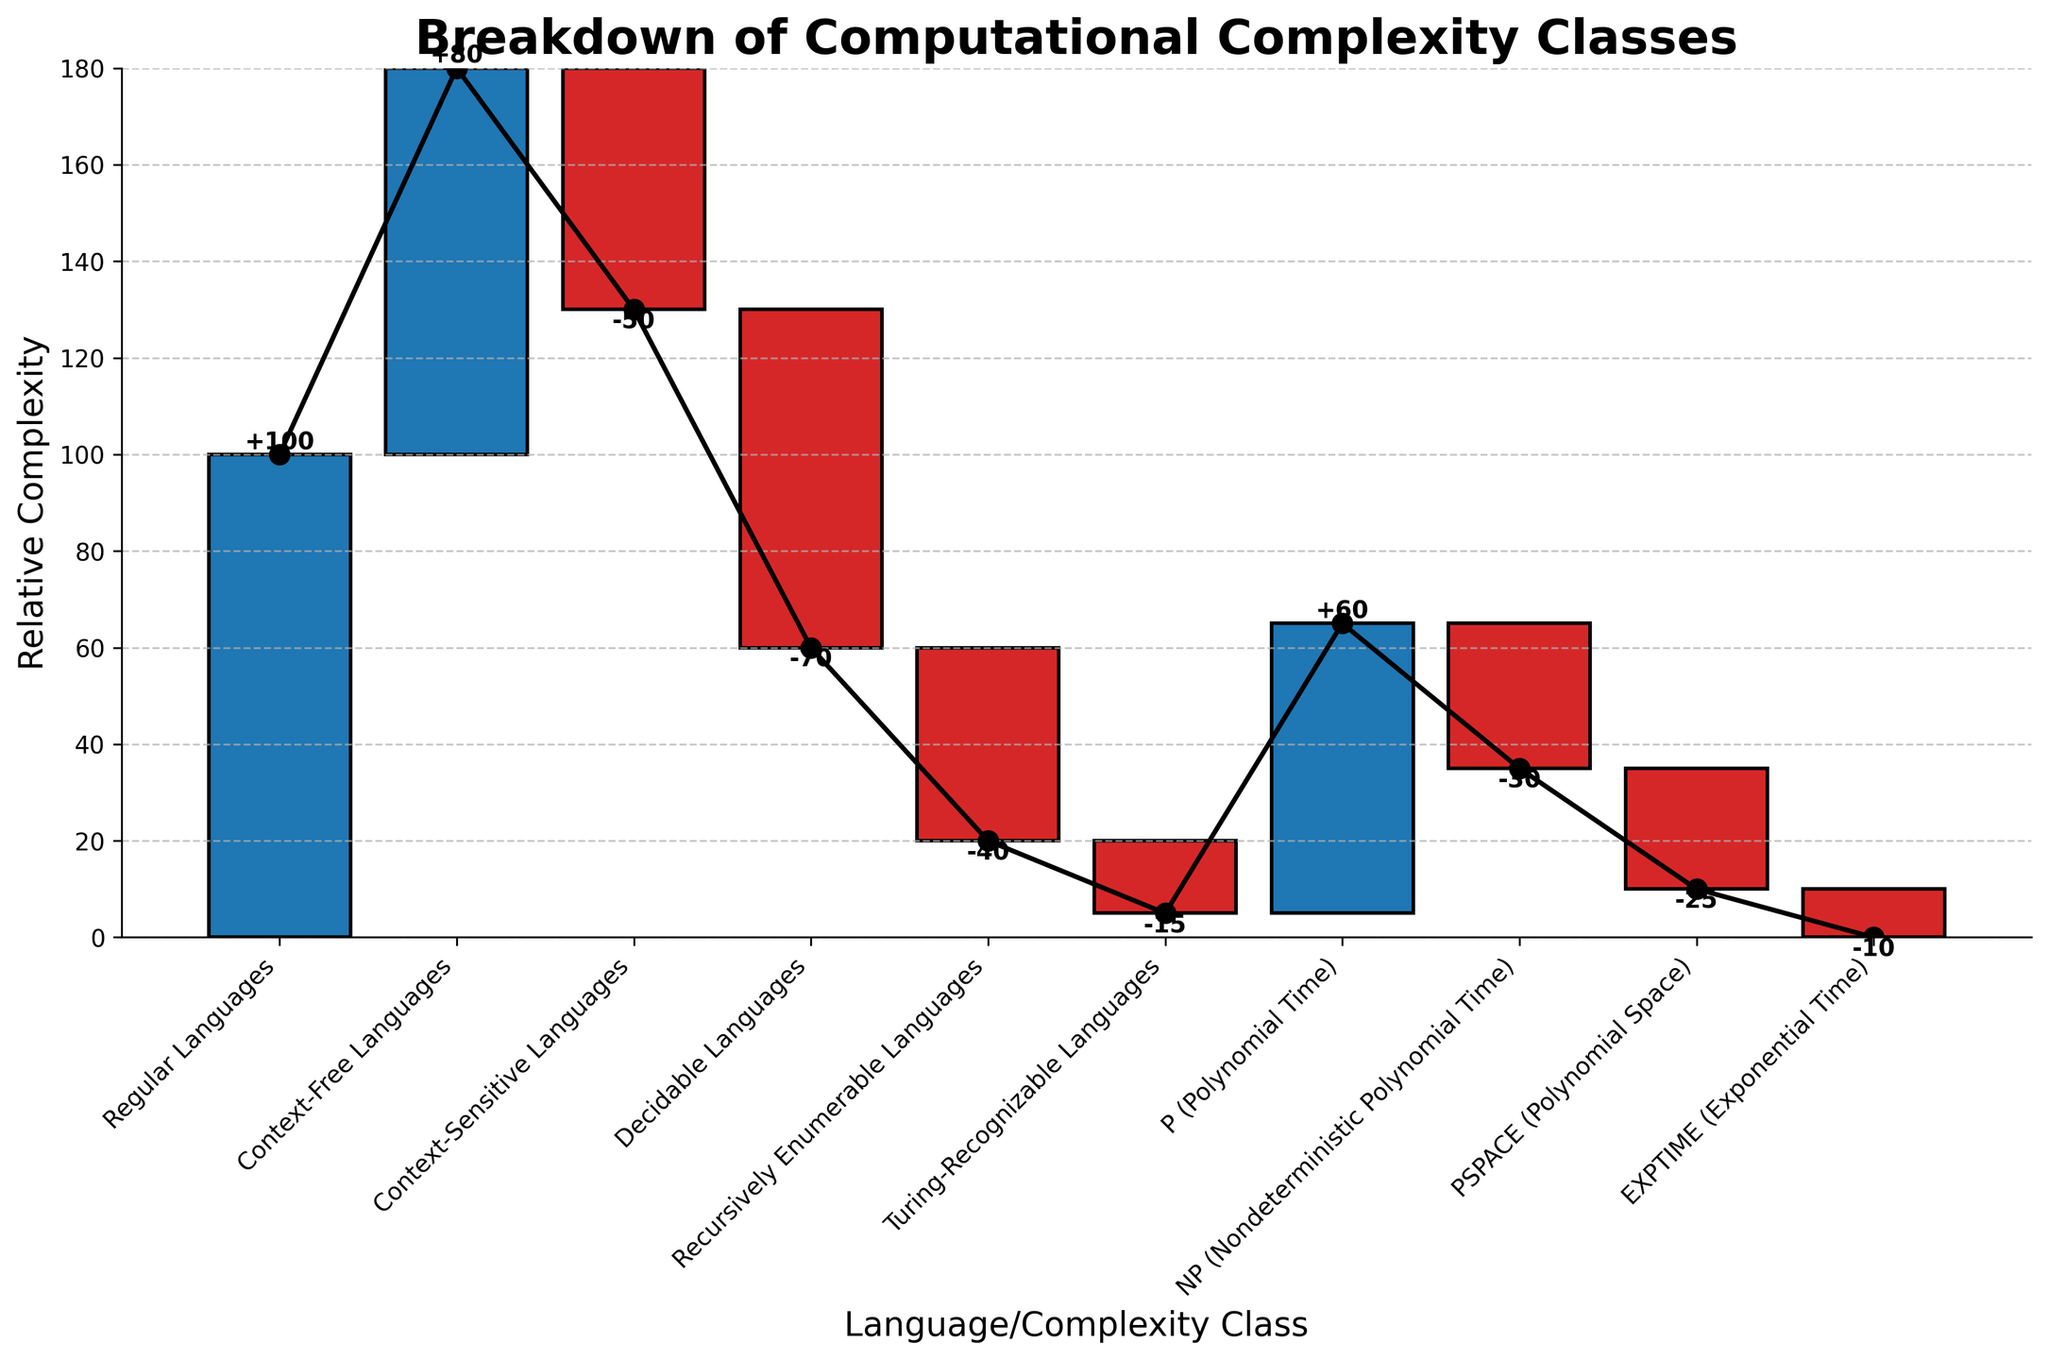What is the title of the figure? The title of the figure is usually displayed at the top in larger and bolder text. By looking at the top of the chart, you can see that the title reads "Breakdown of Computational Complexity Classes".
Answer: Breakdown of Computational Complexity Classes How many different categories are shown in the figure? The number of categories can be determined by counting the distinct labels along the x-axis of the chart. By counting these, we find there are a total of 10 categories.
Answer: 10 Which category has the highest positive value? To identify the highest positive value, compare all positive values shown on the bars. "Regular Languages" has a value of 100, which is higher than any other positive value in this dataset.
Answer: Regular Languages How much does the "P (Polynomial Time)" category contribute to the overall complexity? Referring to the figure, the "P (Polynomial Time)" category shows a positive value. By reading the value label above the bar, we see it contributes +60 to the overall complexity.
Answer: +60 What is the cumulative complexity after "Context-Free Languages"? To find the cumulative complexity after "Context-Free Languages", add the first two values: 100 (Regular Languages) + 80 (Context-Free Languages) = 180. This is confirmed by the point in the cumulative line above the "Context-Free Languages" bar.
Answer: 180 Which category is responsible for the largest decrease in complexity? The largest decrease in complexity can be identified by comparing the negative values on the bars. "Decidable Languages" has the largest negative value at -70.
Answer: Decidable Languages What is the cumulative complexity at the end of the chart? The cumulative complexity at the end can be found by adding all values in sequence: 100 + 80 - 50 - 70 - 40 - 15 + 60 - 30 - 25 - 10 = 0. This corresponds to the final point on the cumulative line.
Answer: 0 What is the cumulative complexity after "Decidable Languages"? Add the values sequentially up to and including "Decidable Languages": 100 (Regular Languages) + 80 (Context-Free Languages) - 50 (Context-Sensitive Languages) - 70 (Decidable Languages) = 60.
Answer: 60 How is the color coding of bars determined in the figure? The colors of the bars are used to distinguish positive from negative values. Positive values are indicated by blue bars, and negative values by red bars.
Answer: Positive: Blue, Negative: Red 